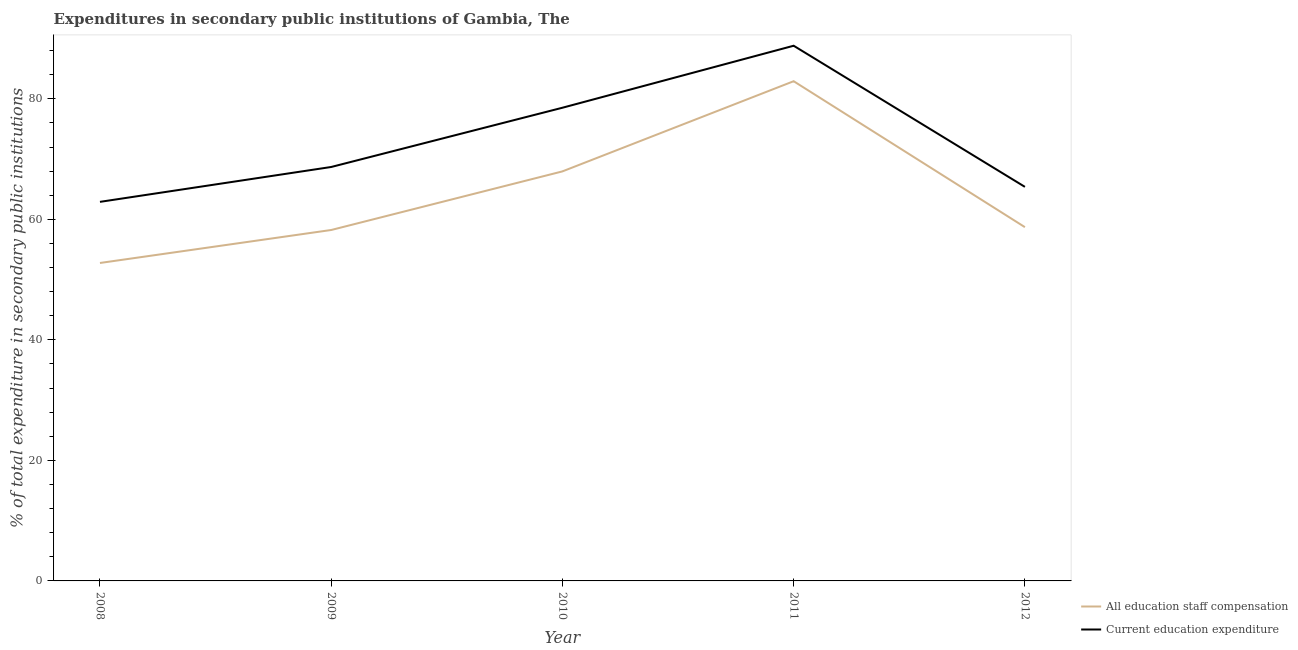How many different coloured lines are there?
Give a very brief answer. 2. Does the line corresponding to expenditure in staff compensation intersect with the line corresponding to expenditure in education?
Your answer should be compact. No. What is the expenditure in staff compensation in 2009?
Your answer should be compact. 58.23. Across all years, what is the maximum expenditure in education?
Keep it short and to the point. 88.81. Across all years, what is the minimum expenditure in education?
Provide a short and direct response. 62.9. In which year was the expenditure in staff compensation maximum?
Offer a terse response. 2011. What is the total expenditure in staff compensation in the graph?
Your response must be concise. 320.57. What is the difference between the expenditure in education in 2011 and that in 2012?
Offer a terse response. 23.42. What is the difference between the expenditure in education in 2010 and the expenditure in staff compensation in 2008?
Your answer should be compact. 25.76. What is the average expenditure in staff compensation per year?
Your answer should be compact. 64.11. In the year 2011, what is the difference between the expenditure in staff compensation and expenditure in education?
Your response must be concise. -5.89. What is the ratio of the expenditure in staff compensation in 2008 to that in 2012?
Provide a succinct answer. 0.9. Is the expenditure in staff compensation in 2011 less than that in 2012?
Provide a short and direct response. No. What is the difference between the highest and the second highest expenditure in education?
Keep it short and to the point. 10.29. What is the difference between the highest and the lowest expenditure in staff compensation?
Offer a terse response. 30.16. Is the sum of the expenditure in staff compensation in 2008 and 2012 greater than the maximum expenditure in education across all years?
Provide a succinct answer. Yes. Does the expenditure in staff compensation monotonically increase over the years?
Give a very brief answer. No. Is the expenditure in education strictly greater than the expenditure in staff compensation over the years?
Give a very brief answer. Yes. Does the graph contain any zero values?
Give a very brief answer. No. Does the graph contain grids?
Make the answer very short. No. Where does the legend appear in the graph?
Give a very brief answer. Bottom right. How many legend labels are there?
Keep it short and to the point. 2. How are the legend labels stacked?
Offer a terse response. Vertical. What is the title of the graph?
Keep it short and to the point. Expenditures in secondary public institutions of Gambia, The. Does "Forest land" appear as one of the legend labels in the graph?
Your answer should be very brief. No. What is the label or title of the X-axis?
Your answer should be compact. Year. What is the label or title of the Y-axis?
Ensure brevity in your answer.  % of total expenditure in secondary public institutions. What is the % of total expenditure in secondary public institutions in All education staff compensation in 2008?
Keep it short and to the point. 52.76. What is the % of total expenditure in secondary public institutions in Current education expenditure in 2008?
Make the answer very short. 62.9. What is the % of total expenditure in secondary public institutions of All education staff compensation in 2009?
Make the answer very short. 58.23. What is the % of total expenditure in secondary public institutions of Current education expenditure in 2009?
Keep it short and to the point. 68.69. What is the % of total expenditure in secondary public institutions in All education staff compensation in 2010?
Provide a succinct answer. 67.96. What is the % of total expenditure in secondary public institutions of Current education expenditure in 2010?
Ensure brevity in your answer.  78.52. What is the % of total expenditure in secondary public institutions in All education staff compensation in 2011?
Offer a terse response. 82.92. What is the % of total expenditure in secondary public institutions in Current education expenditure in 2011?
Provide a short and direct response. 88.81. What is the % of total expenditure in secondary public institutions of All education staff compensation in 2012?
Keep it short and to the point. 58.7. What is the % of total expenditure in secondary public institutions in Current education expenditure in 2012?
Offer a very short reply. 65.39. Across all years, what is the maximum % of total expenditure in secondary public institutions in All education staff compensation?
Your response must be concise. 82.92. Across all years, what is the maximum % of total expenditure in secondary public institutions of Current education expenditure?
Give a very brief answer. 88.81. Across all years, what is the minimum % of total expenditure in secondary public institutions in All education staff compensation?
Your answer should be very brief. 52.76. Across all years, what is the minimum % of total expenditure in secondary public institutions of Current education expenditure?
Your response must be concise. 62.9. What is the total % of total expenditure in secondary public institutions in All education staff compensation in the graph?
Provide a succinct answer. 320.57. What is the total % of total expenditure in secondary public institutions in Current education expenditure in the graph?
Offer a terse response. 364.3. What is the difference between the % of total expenditure in secondary public institutions of All education staff compensation in 2008 and that in 2009?
Provide a short and direct response. -5.47. What is the difference between the % of total expenditure in secondary public institutions in Current education expenditure in 2008 and that in 2009?
Your answer should be compact. -5.79. What is the difference between the % of total expenditure in secondary public institutions in All education staff compensation in 2008 and that in 2010?
Provide a short and direct response. -15.2. What is the difference between the % of total expenditure in secondary public institutions of Current education expenditure in 2008 and that in 2010?
Keep it short and to the point. -15.62. What is the difference between the % of total expenditure in secondary public institutions of All education staff compensation in 2008 and that in 2011?
Ensure brevity in your answer.  -30.16. What is the difference between the % of total expenditure in secondary public institutions in Current education expenditure in 2008 and that in 2011?
Keep it short and to the point. -25.91. What is the difference between the % of total expenditure in secondary public institutions in All education staff compensation in 2008 and that in 2012?
Your answer should be compact. -5.94. What is the difference between the % of total expenditure in secondary public institutions of Current education expenditure in 2008 and that in 2012?
Your answer should be very brief. -2.49. What is the difference between the % of total expenditure in secondary public institutions in All education staff compensation in 2009 and that in 2010?
Provide a succinct answer. -9.73. What is the difference between the % of total expenditure in secondary public institutions of Current education expenditure in 2009 and that in 2010?
Your answer should be compact. -9.83. What is the difference between the % of total expenditure in secondary public institutions of All education staff compensation in 2009 and that in 2011?
Provide a short and direct response. -24.69. What is the difference between the % of total expenditure in secondary public institutions in Current education expenditure in 2009 and that in 2011?
Your answer should be very brief. -20.12. What is the difference between the % of total expenditure in secondary public institutions in All education staff compensation in 2009 and that in 2012?
Your response must be concise. -0.47. What is the difference between the % of total expenditure in secondary public institutions of Current education expenditure in 2009 and that in 2012?
Give a very brief answer. 3.3. What is the difference between the % of total expenditure in secondary public institutions of All education staff compensation in 2010 and that in 2011?
Your answer should be very brief. -14.96. What is the difference between the % of total expenditure in secondary public institutions of Current education expenditure in 2010 and that in 2011?
Provide a succinct answer. -10.29. What is the difference between the % of total expenditure in secondary public institutions of All education staff compensation in 2010 and that in 2012?
Ensure brevity in your answer.  9.25. What is the difference between the % of total expenditure in secondary public institutions of Current education expenditure in 2010 and that in 2012?
Provide a short and direct response. 13.13. What is the difference between the % of total expenditure in secondary public institutions of All education staff compensation in 2011 and that in 2012?
Provide a short and direct response. 24.22. What is the difference between the % of total expenditure in secondary public institutions of Current education expenditure in 2011 and that in 2012?
Your answer should be very brief. 23.42. What is the difference between the % of total expenditure in secondary public institutions of All education staff compensation in 2008 and the % of total expenditure in secondary public institutions of Current education expenditure in 2009?
Keep it short and to the point. -15.93. What is the difference between the % of total expenditure in secondary public institutions in All education staff compensation in 2008 and the % of total expenditure in secondary public institutions in Current education expenditure in 2010?
Your answer should be very brief. -25.76. What is the difference between the % of total expenditure in secondary public institutions of All education staff compensation in 2008 and the % of total expenditure in secondary public institutions of Current education expenditure in 2011?
Provide a short and direct response. -36.05. What is the difference between the % of total expenditure in secondary public institutions in All education staff compensation in 2008 and the % of total expenditure in secondary public institutions in Current education expenditure in 2012?
Give a very brief answer. -12.63. What is the difference between the % of total expenditure in secondary public institutions of All education staff compensation in 2009 and the % of total expenditure in secondary public institutions of Current education expenditure in 2010?
Your answer should be very brief. -20.29. What is the difference between the % of total expenditure in secondary public institutions in All education staff compensation in 2009 and the % of total expenditure in secondary public institutions in Current education expenditure in 2011?
Your response must be concise. -30.57. What is the difference between the % of total expenditure in secondary public institutions of All education staff compensation in 2009 and the % of total expenditure in secondary public institutions of Current education expenditure in 2012?
Offer a very short reply. -7.16. What is the difference between the % of total expenditure in secondary public institutions in All education staff compensation in 2010 and the % of total expenditure in secondary public institutions in Current education expenditure in 2011?
Offer a very short reply. -20.85. What is the difference between the % of total expenditure in secondary public institutions of All education staff compensation in 2010 and the % of total expenditure in secondary public institutions of Current education expenditure in 2012?
Offer a terse response. 2.57. What is the difference between the % of total expenditure in secondary public institutions in All education staff compensation in 2011 and the % of total expenditure in secondary public institutions in Current education expenditure in 2012?
Provide a short and direct response. 17.53. What is the average % of total expenditure in secondary public institutions in All education staff compensation per year?
Provide a succinct answer. 64.11. What is the average % of total expenditure in secondary public institutions in Current education expenditure per year?
Keep it short and to the point. 72.86. In the year 2008, what is the difference between the % of total expenditure in secondary public institutions of All education staff compensation and % of total expenditure in secondary public institutions of Current education expenditure?
Ensure brevity in your answer.  -10.14. In the year 2009, what is the difference between the % of total expenditure in secondary public institutions of All education staff compensation and % of total expenditure in secondary public institutions of Current education expenditure?
Your response must be concise. -10.46. In the year 2010, what is the difference between the % of total expenditure in secondary public institutions in All education staff compensation and % of total expenditure in secondary public institutions in Current education expenditure?
Ensure brevity in your answer.  -10.56. In the year 2011, what is the difference between the % of total expenditure in secondary public institutions in All education staff compensation and % of total expenditure in secondary public institutions in Current education expenditure?
Offer a terse response. -5.89. In the year 2012, what is the difference between the % of total expenditure in secondary public institutions in All education staff compensation and % of total expenditure in secondary public institutions in Current education expenditure?
Give a very brief answer. -6.68. What is the ratio of the % of total expenditure in secondary public institutions in All education staff compensation in 2008 to that in 2009?
Your response must be concise. 0.91. What is the ratio of the % of total expenditure in secondary public institutions of Current education expenditure in 2008 to that in 2009?
Provide a short and direct response. 0.92. What is the ratio of the % of total expenditure in secondary public institutions in All education staff compensation in 2008 to that in 2010?
Make the answer very short. 0.78. What is the ratio of the % of total expenditure in secondary public institutions in Current education expenditure in 2008 to that in 2010?
Give a very brief answer. 0.8. What is the ratio of the % of total expenditure in secondary public institutions in All education staff compensation in 2008 to that in 2011?
Keep it short and to the point. 0.64. What is the ratio of the % of total expenditure in secondary public institutions of Current education expenditure in 2008 to that in 2011?
Provide a succinct answer. 0.71. What is the ratio of the % of total expenditure in secondary public institutions in All education staff compensation in 2008 to that in 2012?
Provide a short and direct response. 0.9. What is the ratio of the % of total expenditure in secondary public institutions in Current education expenditure in 2008 to that in 2012?
Keep it short and to the point. 0.96. What is the ratio of the % of total expenditure in secondary public institutions of All education staff compensation in 2009 to that in 2010?
Provide a short and direct response. 0.86. What is the ratio of the % of total expenditure in secondary public institutions of Current education expenditure in 2009 to that in 2010?
Make the answer very short. 0.87. What is the ratio of the % of total expenditure in secondary public institutions in All education staff compensation in 2009 to that in 2011?
Offer a very short reply. 0.7. What is the ratio of the % of total expenditure in secondary public institutions in Current education expenditure in 2009 to that in 2011?
Your response must be concise. 0.77. What is the ratio of the % of total expenditure in secondary public institutions of Current education expenditure in 2009 to that in 2012?
Your answer should be very brief. 1.05. What is the ratio of the % of total expenditure in secondary public institutions of All education staff compensation in 2010 to that in 2011?
Provide a succinct answer. 0.82. What is the ratio of the % of total expenditure in secondary public institutions in Current education expenditure in 2010 to that in 2011?
Keep it short and to the point. 0.88. What is the ratio of the % of total expenditure in secondary public institutions in All education staff compensation in 2010 to that in 2012?
Offer a terse response. 1.16. What is the ratio of the % of total expenditure in secondary public institutions of Current education expenditure in 2010 to that in 2012?
Ensure brevity in your answer.  1.2. What is the ratio of the % of total expenditure in secondary public institutions of All education staff compensation in 2011 to that in 2012?
Provide a succinct answer. 1.41. What is the ratio of the % of total expenditure in secondary public institutions in Current education expenditure in 2011 to that in 2012?
Your answer should be very brief. 1.36. What is the difference between the highest and the second highest % of total expenditure in secondary public institutions of All education staff compensation?
Your answer should be very brief. 14.96. What is the difference between the highest and the second highest % of total expenditure in secondary public institutions of Current education expenditure?
Give a very brief answer. 10.29. What is the difference between the highest and the lowest % of total expenditure in secondary public institutions of All education staff compensation?
Provide a succinct answer. 30.16. What is the difference between the highest and the lowest % of total expenditure in secondary public institutions of Current education expenditure?
Your answer should be compact. 25.91. 